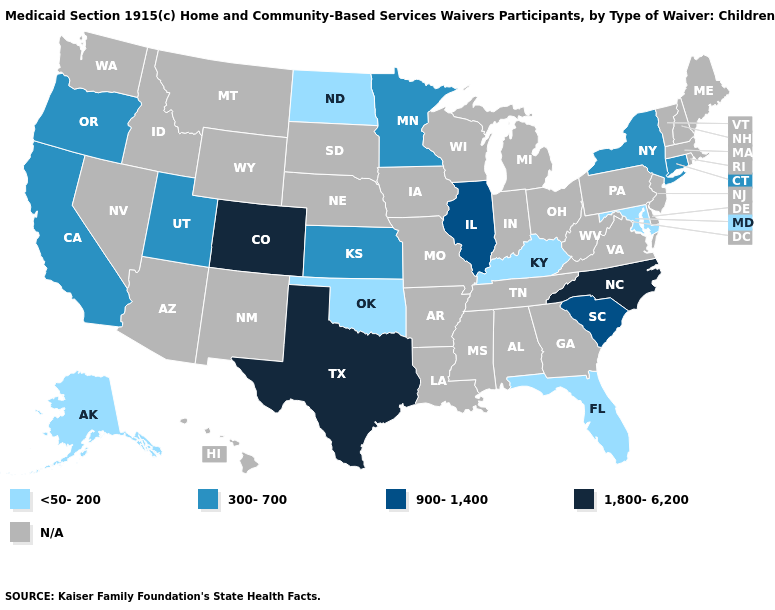Among the states that border South Dakota , which have the lowest value?
Short answer required. North Dakota. Which states have the lowest value in the USA?
Write a very short answer. Alaska, Florida, Kentucky, Maryland, North Dakota, Oklahoma. What is the value of Hawaii?
Concise answer only. N/A. Which states hav the highest value in the Northeast?
Keep it brief. Connecticut, New York. Among the states that border South Dakota , does North Dakota have the lowest value?
Short answer required. Yes. What is the highest value in states that border North Carolina?
Be succinct. 900-1,400. What is the highest value in the MidWest ?
Write a very short answer. 900-1,400. Among the states that border Missouri , does Oklahoma have the highest value?
Be succinct. No. What is the value of Oregon?
Answer briefly. 300-700. Name the states that have a value in the range <50-200?
Answer briefly. Alaska, Florida, Kentucky, Maryland, North Dakota, Oklahoma. What is the value of Nevada?
Short answer required. N/A. 